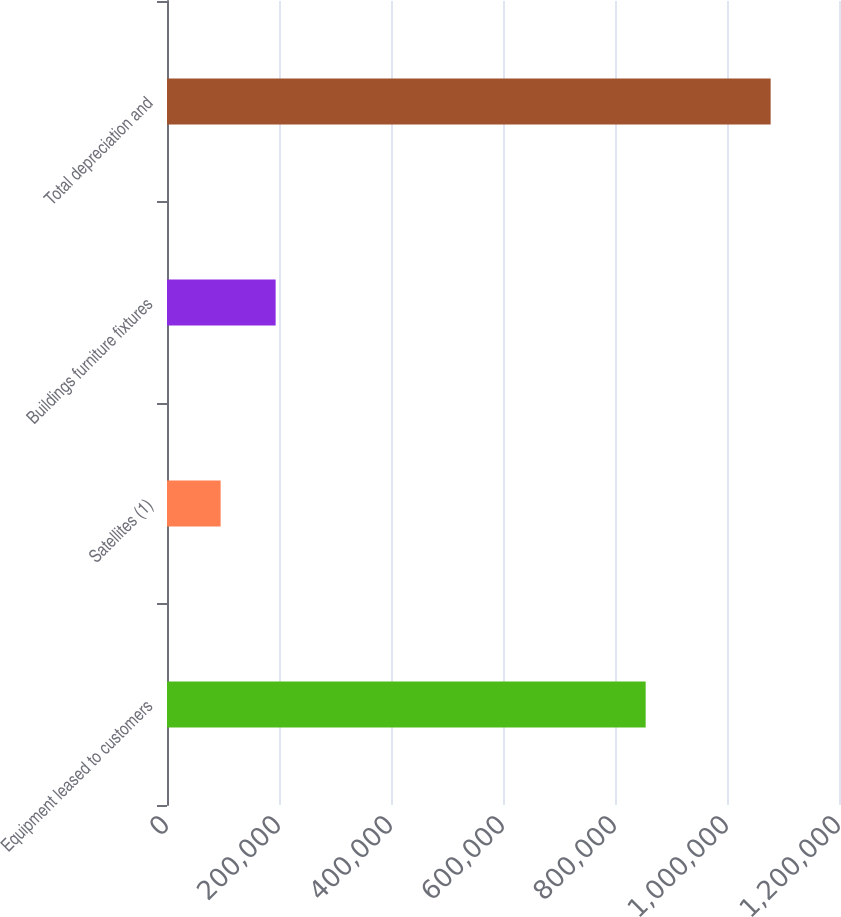<chart> <loc_0><loc_0><loc_500><loc_500><bar_chart><fcel>Equipment leased to customers<fcel>Satellites (1)<fcel>Buildings furniture fixtures<fcel>Total depreciation and<nl><fcel>854759<fcel>95766<fcel>193983<fcel>1.07794e+06<nl></chart> 